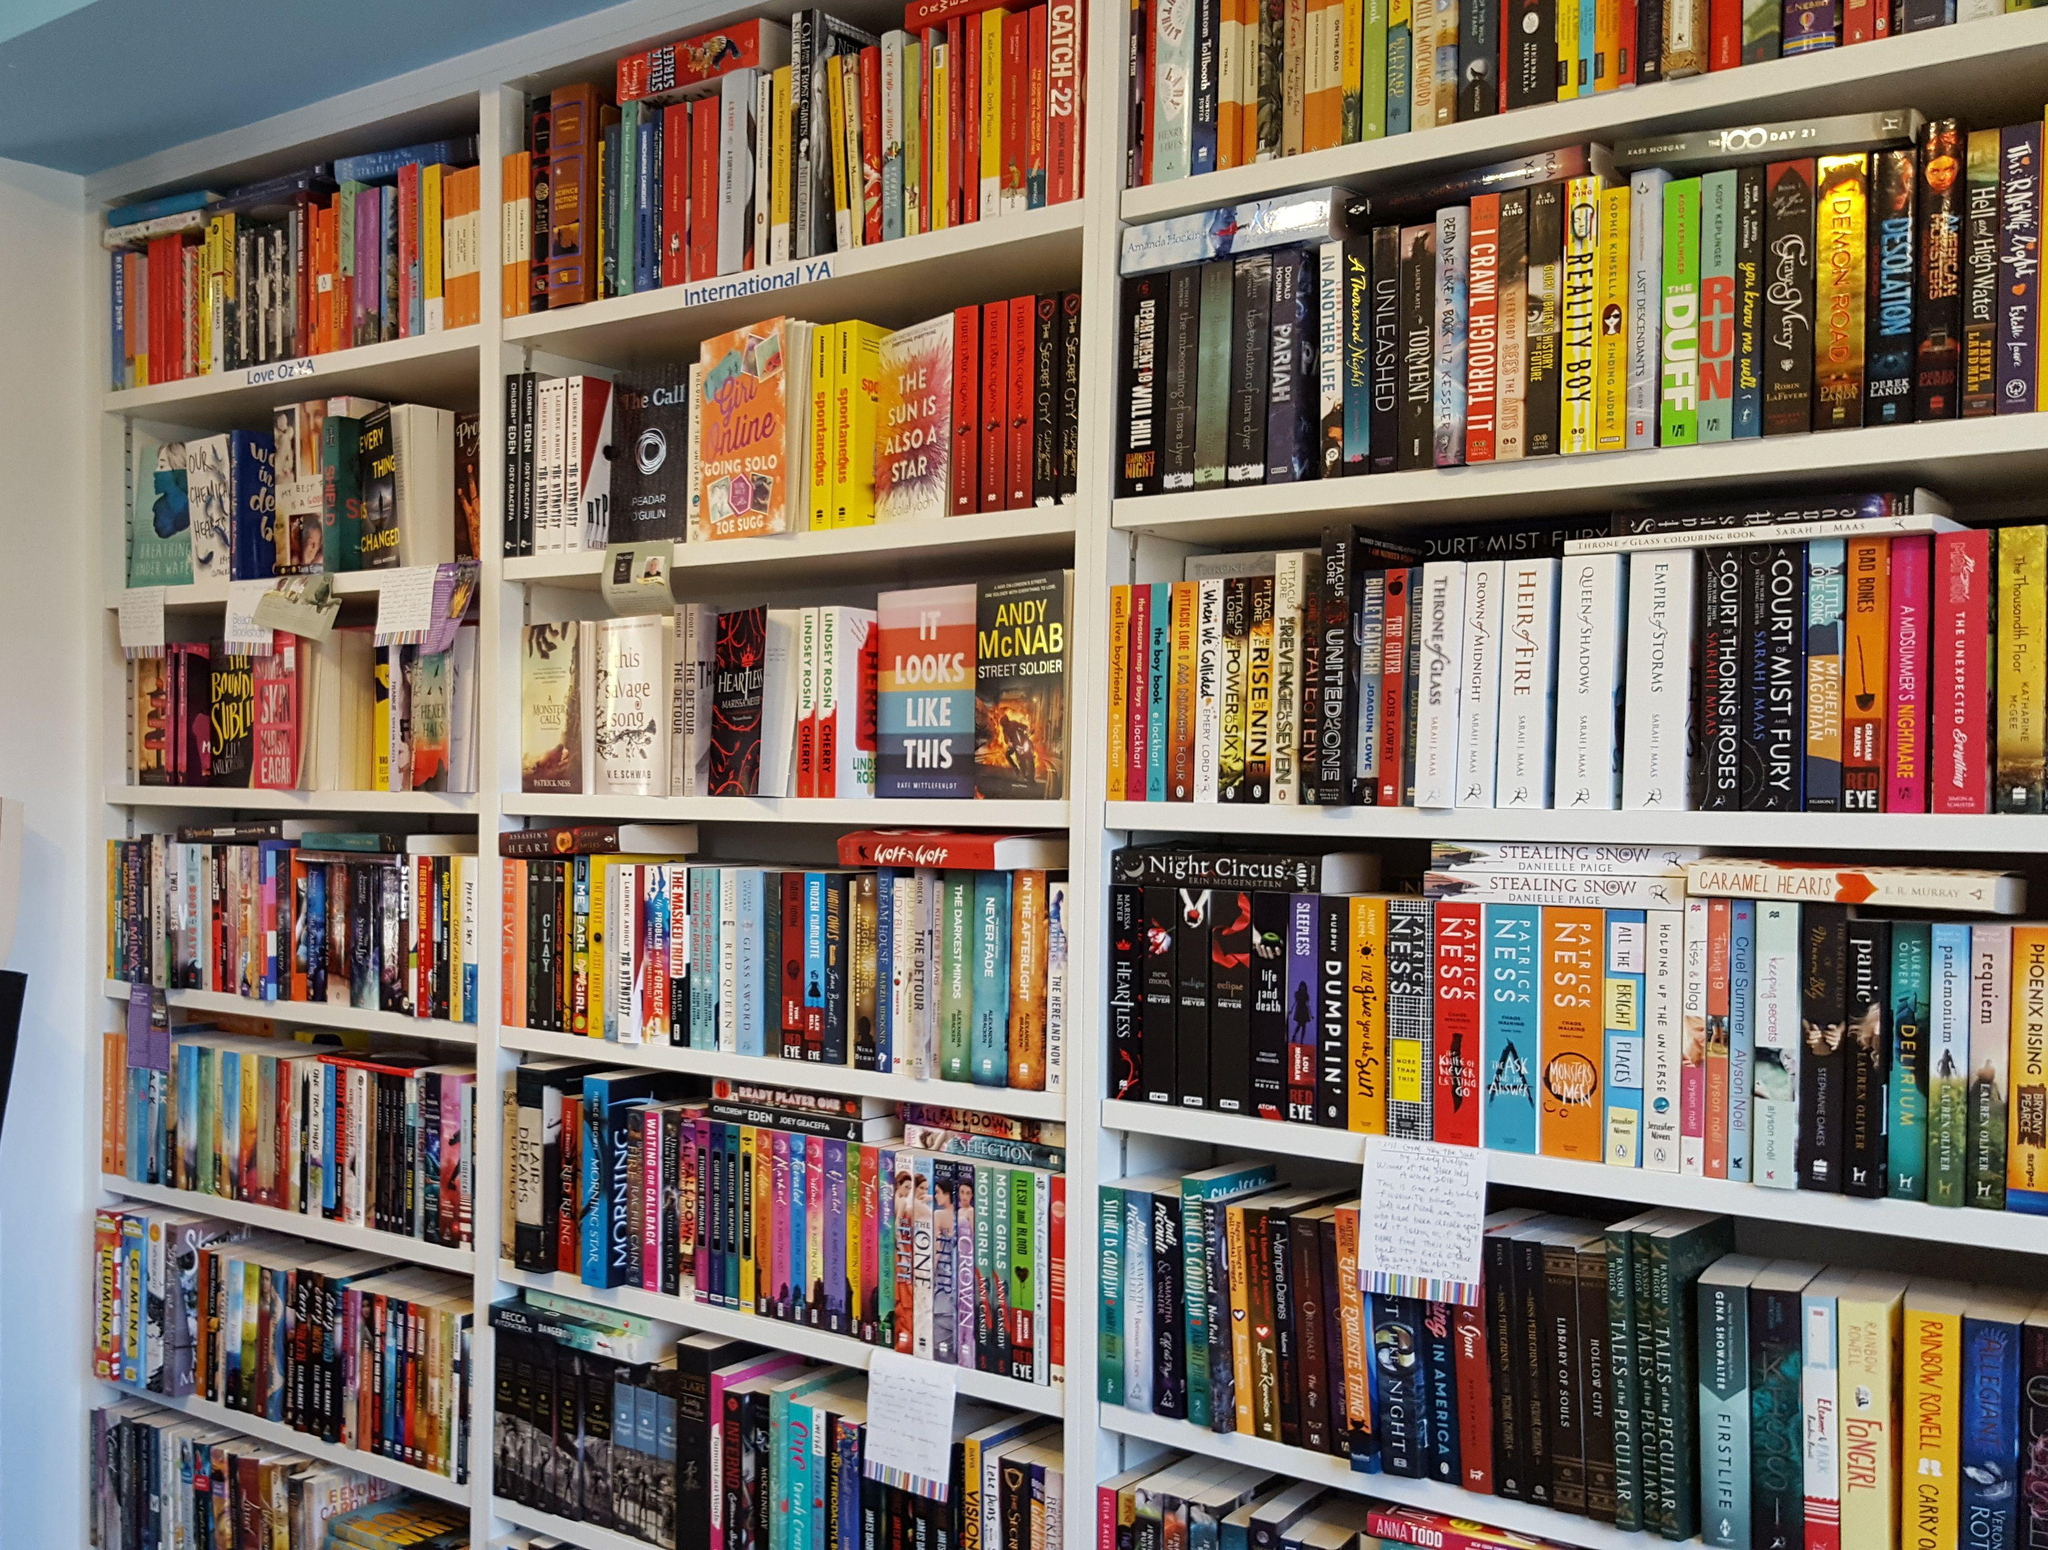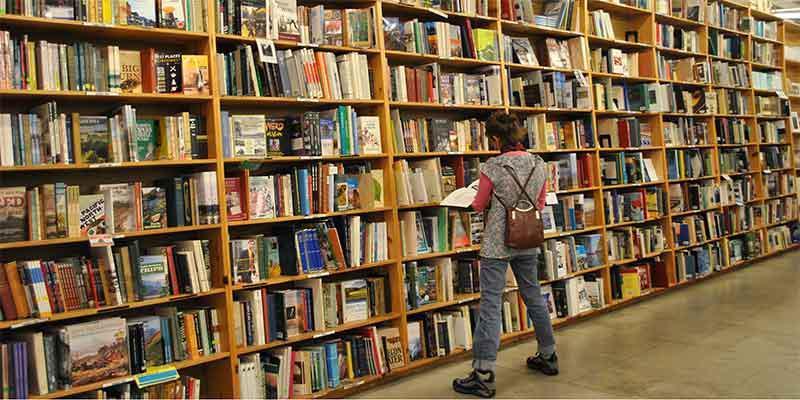The first image is the image on the left, the second image is the image on the right. For the images shown, is this caption "In at least one image there is a woman with an open book in her hands standing in front of a bookshelf on the left." true? Answer yes or no. Yes. The first image is the image on the left, the second image is the image on the right. For the images shown, is this caption "The right image features one woman with a bag slung on her back, standing with her back to the camera and facing leftward toward a solid wall of books on shelves." true? Answer yes or no. Yes. 